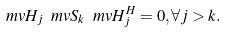Convert formula to latex. <formula><loc_0><loc_0><loc_500><loc_500>\ m v { H } _ { j } \ m v { S } _ { k } \ m v { H } ^ { H } _ { j } = 0 , \forall j > k .</formula> 